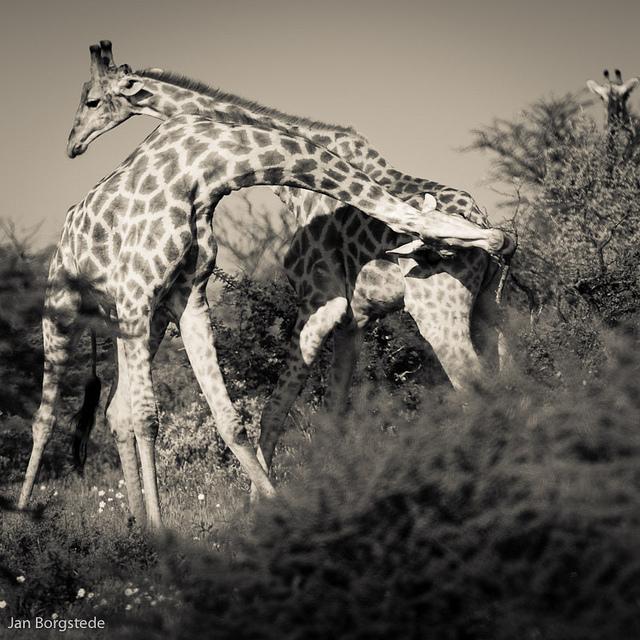What are these animals?
Give a very brief answer. Giraffes. How many giraffes are there?
Be succinct. 2. Where is this?
Keep it brief. Africa. 